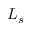<formula> <loc_0><loc_0><loc_500><loc_500>L _ { s }</formula> 